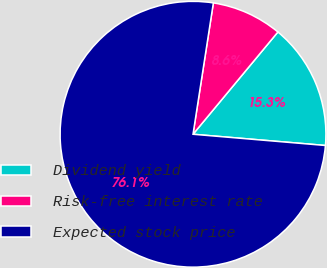<chart> <loc_0><loc_0><loc_500><loc_500><pie_chart><fcel>Dividend yield<fcel>Risk-free interest rate<fcel>Expected stock price<nl><fcel>15.32%<fcel>8.58%<fcel>76.1%<nl></chart> 